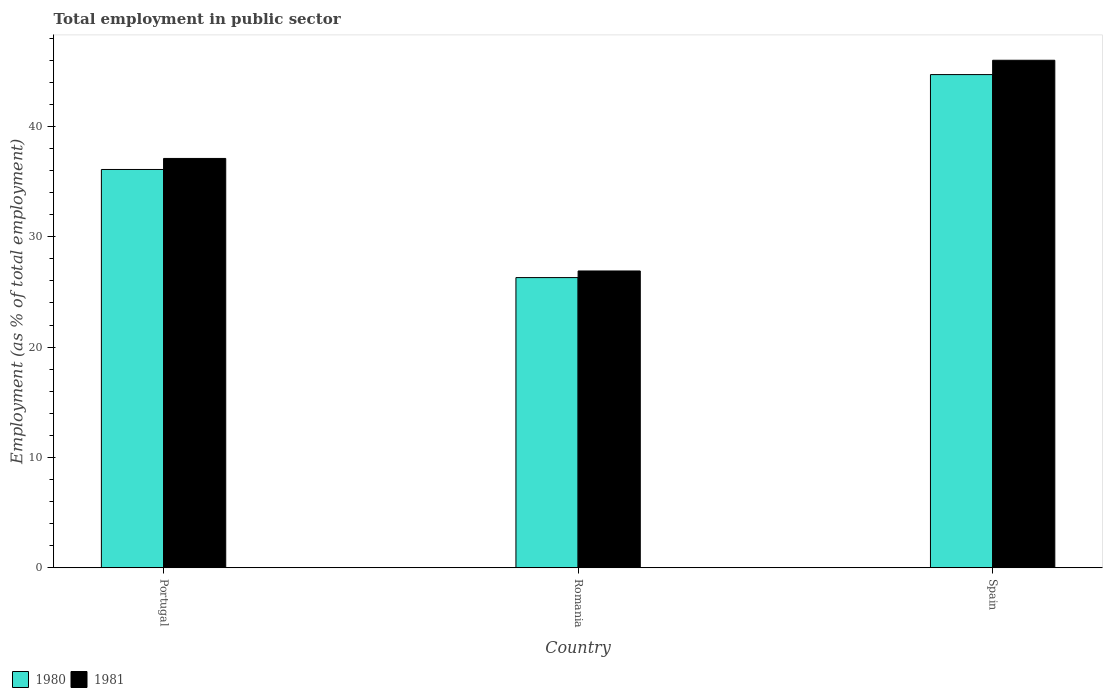How many different coloured bars are there?
Offer a terse response. 2. Are the number of bars on each tick of the X-axis equal?
Offer a terse response. Yes. What is the label of the 2nd group of bars from the left?
Ensure brevity in your answer.  Romania. In how many cases, is the number of bars for a given country not equal to the number of legend labels?
Offer a terse response. 0. What is the employment in public sector in 1981 in Portugal?
Your response must be concise. 37.1. Across all countries, what is the maximum employment in public sector in 1980?
Make the answer very short. 44.7. Across all countries, what is the minimum employment in public sector in 1980?
Make the answer very short. 26.3. In which country was the employment in public sector in 1980 maximum?
Provide a succinct answer. Spain. In which country was the employment in public sector in 1980 minimum?
Keep it short and to the point. Romania. What is the total employment in public sector in 1981 in the graph?
Your answer should be very brief. 110. What is the difference between the employment in public sector in 1980 in Portugal and that in Spain?
Your answer should be compact. -8.6. What is the difference between the employment in public sector in 1981 in Portugal and the employment in public sector in 1980 in Spain?
Ensure brevity in your answer.  -7.6. What is the average employment in public sector in 1980 per country?
Offer a very short reply. 35.7. What is the difference between the employment in public sector of/in 1980 and employment in public sector of/in 1981 in Portugal?
Give a very brief answer. -1. In how many countries, is the employment in public sector in 1980 greater than 40 %?
Your response must be concise. 1. What is the ratio of the employment in public sector in 1980 in Romania to that in Spain?
Provide a succinct answer. 0.59. Is the employment in public sector in 1981 in Romania less than that in Spain?
Offer a terse response. Yes. Is the difference between the employment in public sector in 1980 in Romania and Spain greater than the difference between the employment in public sector in 1981 in Romania and Spain?
Keep it short and to the point. Yes. What is the difference between the highest and the second highest employment in public sector in 1981?
Make the answer very short. -10.2. What is the difference between the highest and the lowest employment in public sector in 1980?
Offer a very short reply. 18.4. Is the sum of the employment in public sector in 1981 in Portugal and Spain greater than the maximum employment in public sector in 1980 across all countries?
Give a very brief answer. Yes. What does the 1st bar from the left in Portugal represents?
Make the answer very short. 1980. What does the 2nd bar from the right in Romania represents?
Ensure brevity in your answer.  1980. Are all the bars in the graph horizontal?
Offer a terse response. No. What is the difference between two consecutive major ticks on the Y-axis?
Offer a terse response. 10. Does the graph contain any zero values?
Offer a very short reply. No. Does the graph contain grids?
Your response must be concise. No. Where does the legend appear in the graph?
Offer a terse response. Bottom left. How many legend labels are there?
Your answer should be compact. 2. What is the title of the graph?
Keep it short and to the point. Total employment in public sector. Does "1997" appear as one of the legend labels in the graph?
Keep it short and to the point. No. What is the label or title of the Y-axis?
Ensure brevity in your answer.  Employment (as % of total employment). What is the Employment (as % of total employment) of 1980 in Portugal?
Your response must be concise. 36.1. What is the Employment (as % of total employment) in 1981 in Portugal?
Give a very brief answer. 37.1. What is the Employment (as % of total employment) in 1980 in Romania?
Ensure brevity in your answer.  26.3. What is the Employment (as % of total employment) of 1981 in Romania?
Make the answer very short. 26.9. What is the Employment (as % of total employment) in 1980 in Spain?
Your answer should be compact. 44.7. Across all countries, what is the maximum Employment (as % of total employment) of 1980?
Give a very brief answer. 44.7. Across all countries, what is the maximum Employment (as % of total employment) of 1981?
Give a very brief answer. 46. Across all countries, what is the minimum Employment (as % of total employment) in 1980?
Offer a terse response. 26.3. Across all countries, what is the minimum Employment (as % of total employment) of 1981?
Your response must be concise. 26.9. What is the total Employment (as % of total employment) of 1980 in the graph?
Ensure brevity in your answer.  107.1. What is the total Employment (as % of total employment) of 1981 in the graph?
Your response must be concise. 110. What is the difference between the Employment (as % of total employment) of 1980 in Portugal and that in Romania?
Make the answer very short. 9.8. What is the difference between the Employment (as % of total employment) of 1981 in Portugal and that in Romania?
Provide a short and direct response. 10.2. What is the difference between the Employment (as % of total employment) of 1980 in Portugal and that in Spain?
Provide a succinct answer. -8.6. What is the difference between the Employment (as % of total employment) in 1980 in Romania and that in Spain?
Keep it short and to the point. -18.4. What is the difference between the Employment (as % of total employment) in 1981 in Romania and that in Spain?
Give a very brief answer. -19.1. What is the difference between the Employment (as % of total employment) of 1980 in Portugal and the Employment (as % of total employment) of 1981 in Spain?
Provide a succinct answer. -9.9. What is the difference between the Employment (as % of total employment) of 1980 in Romania and the Employment (as % of total employment) of 1981 in Spain?
Provide a short and direct response. -19.7. What is the average Employment (as % of total employment) in 1980 per country?
Give a very brief answer. 35.7. What is the average Employment (as % of total employment) of 1981 per country?
Your answer should be compact. 36.67. What is the difference between the Employment (as % of total employment) in 1980 and Employment (as % of total employment) in 1981 in Portugal?
Offer a terse response. -1. What is the difference between the Employment (as % of total employment) of 1980 and Employment (as % of total employment) of 1981 in Romania?
Give a very brief answer. -0.6. What is the difference between the Employment (as % of total employment) of 1980 and Employment (as % of total employment) of 1981 in Spain?
Your answer should be compact. -1.3. What is the ratio of the Employment (as % of total employment) of 1980 in Portugal to that in Romania?
Your response must be concise. 1.37. What is the ratio of the Employment (as % of total employment) in 1981 in Portugal to that in Romania?
Keep it short and to the point. 1.38. What is the ratio of the Employment (as % of total employment) in 1980 in Portugal to that in Spain?
Your response must be concise. 0.81. What is the ratio of the Employment (as % of total employment) in 1981 in Portugal to that in Spain?
Your response must be concise. 0.81. What is the ratio of the Employment (as % of total employment) in 1980 in Romania to that in Spain?
Provide a succinct answer. 0.59. What is the ratio of the Employment (as % of total employment) in 1981 in Romania to that in Spain?
Your response must be concise. 0.58. What is the difference between the highest and the lowest Employment (as % of total employment) of 1981?
Your answer should be very brief. 19.1. 